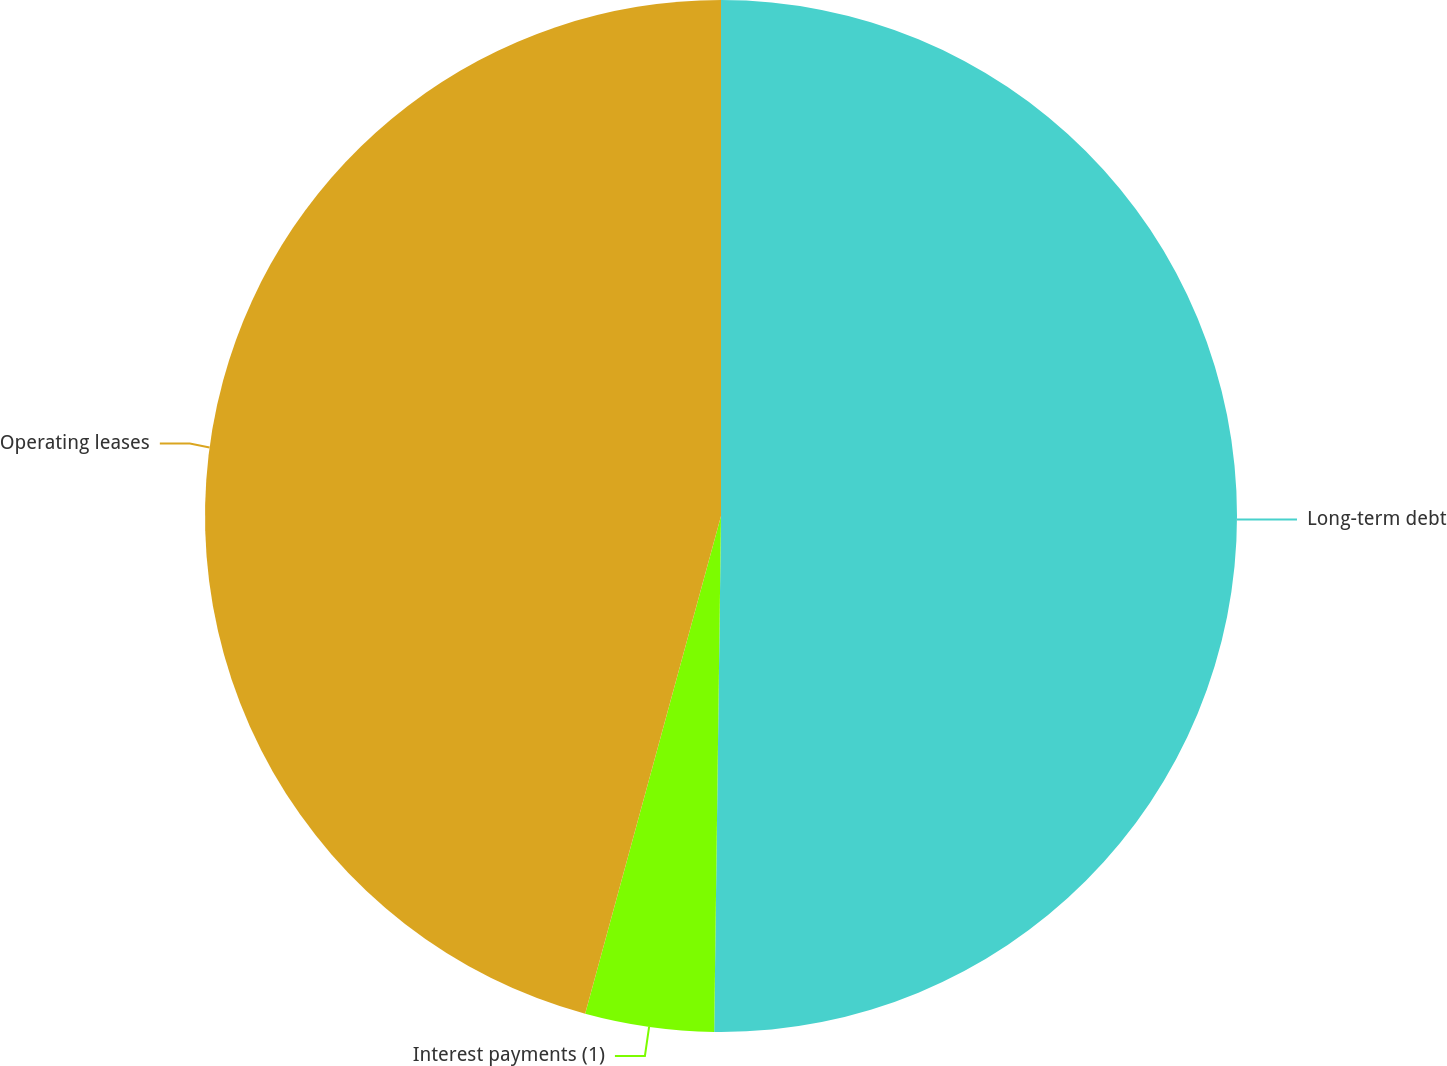Convert chart. <chart><loc_0><loc_0><loc_500><loc_500><pie_chart><fcel>Long-term debt<fcel>Interest payments (1)<fcel>Operating leases<nl><fcel>50.21%<fcel>4.03%<fcel>45.76%<nl></chart> 